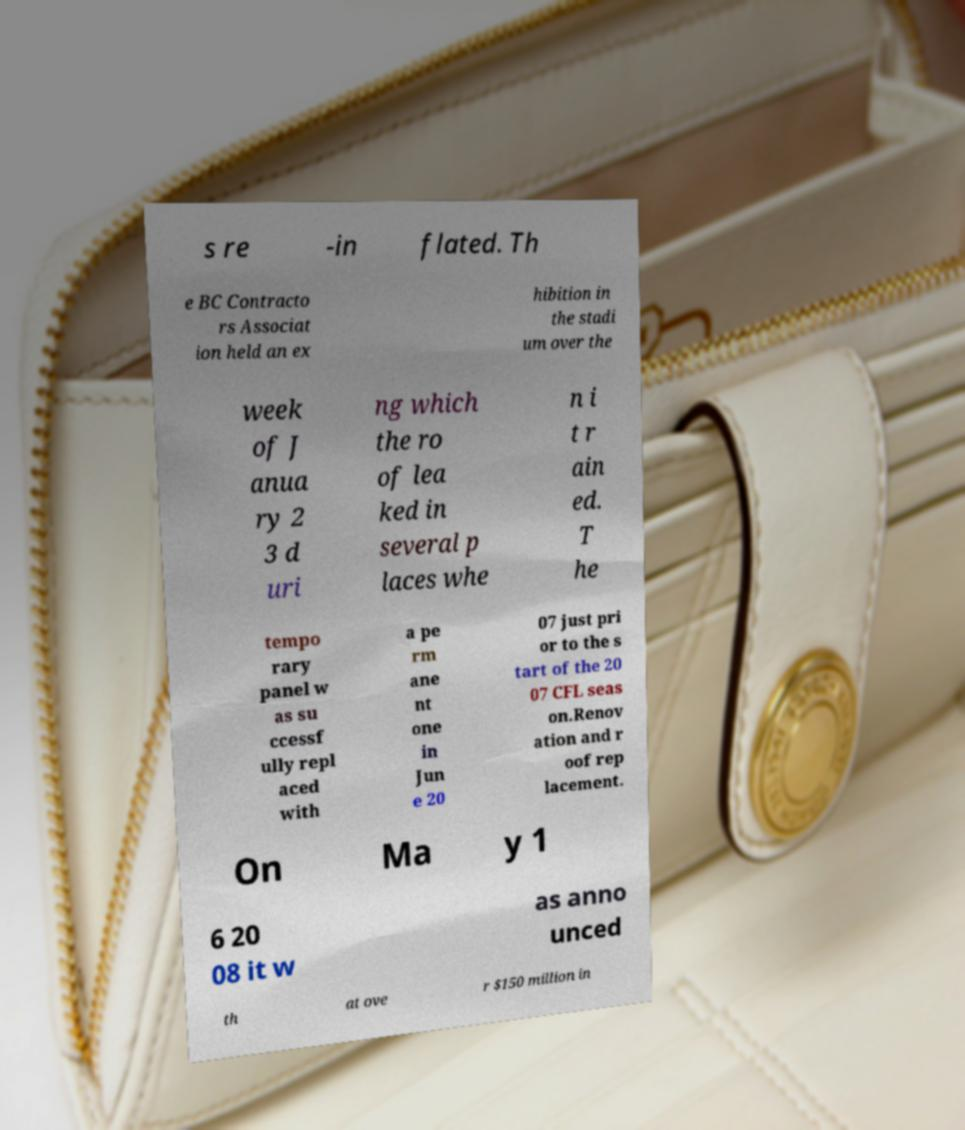Can you read and provide the text displayed in the image?This photo seems to have some interesting text. Can you extract and type it out for me? s re -in flated. Th e BC Contracto rs Associat ion held an ex hibition in the stadi um over the week of J anua ry 2 3 d uri ng which the ro of lea ked in several p laces whe n i t r ain ed. T he tempo rary panel w as su ccessf ully repl aced with a pe rm ane nt one in Jun e 20 07 just pri or to the s tart of the 20 07 CFL seas on.Renov ation and r oof rep lacement. On Ma y 1 6 20 08 it w as anno unced th at ove r $150 million in 